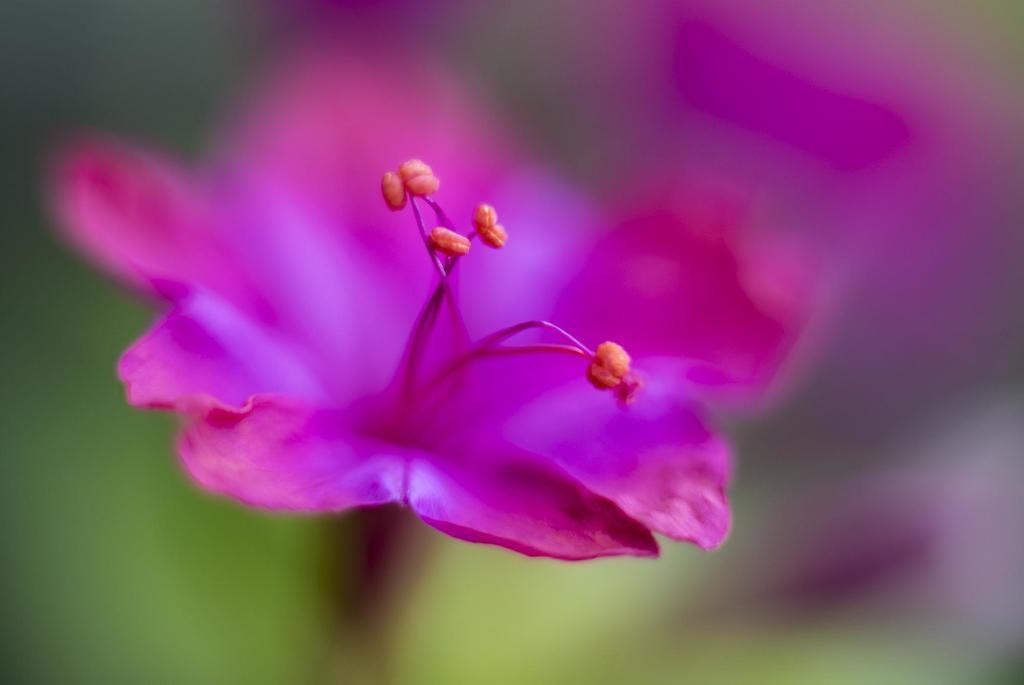What is the main subject of the image? There is a flower in the image. Can you describe the background of the image? The background of the image is blurred. What is the weight of the lace skirt in the image? There is no lace skirt present in the image, so it is not possible to determine its weight. 